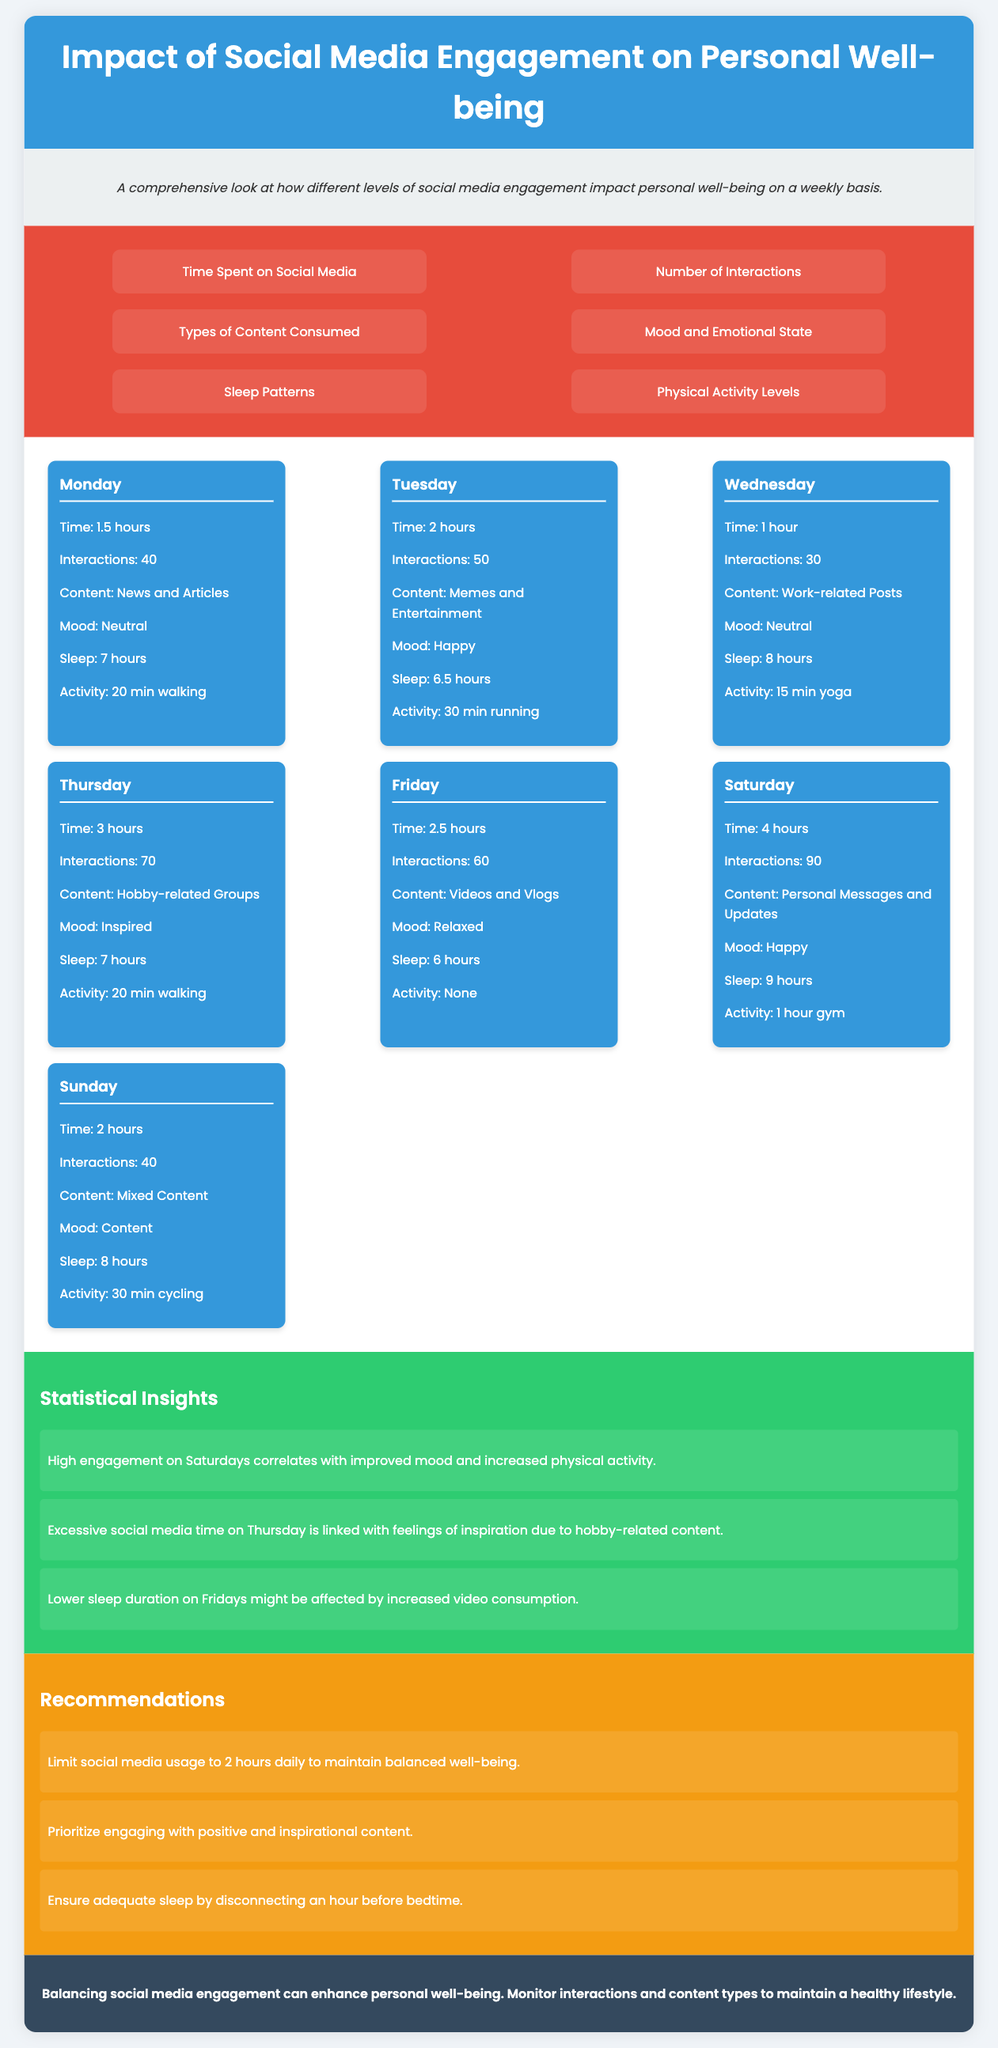what is the time spent on social media on Saturday? The document states that 4 hours were spent on social media on Saturday.
Answer: 4 hours what mood is reported for Tuesday? According to the document, the mood reported for Tuesday is Happy.
Answer: Happy how many interactions were recorded on Thursday? The document indicates that 70 interactions were recorded on Thursday.
Answer: 70 which type of content was consumed on Monday? The document lists News and Articles as the type of content consumed on Monday.
Answer: News and Articles what recommendation is given regarding social media usage? The document recommends limiting social media usage to 2 hours daily to maintain balanced well-being.
Answer: Limit social media usage to 2 hours daily which day had the least sleep duration? The document reveals that Friday had the least sleep duration at 6 hours.
Answer: 6 hours what insight relates excessive social media time? The document notes that excessive social media time on Thursday is linked with feelings of inspiration.
Answer: Feelings of inspiration how many minutes of physical activity were reported on Saturday? The document states that 1 hour gym (60 minutes) of physical activity was reported on Saturday.
Answer: 1 hour gym what is the conclusion regarding social media engagement? The conclusion in the document states that balancing social media engagement can enhance personal well-being.
Answer: Balancing social media engagement can enhance personal well-being 